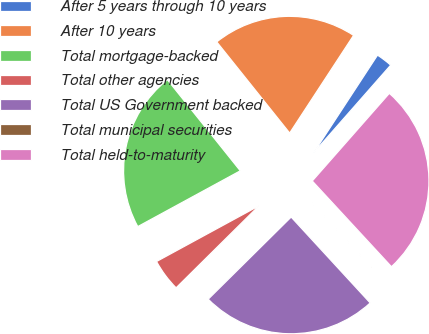Convert chart to OTSL. <chart><loc_0><loc_0><loc_500><loc_500><pie_chart><fcel>After 5 years through 10 years<fcel>After 10 years<fcel>Total mortgage-backed<fcel>Total other agencies<fcel>Total US Government backed<fcel>Total municipal securities<fcel>Total held-to-maturity<nl><fcel>2.26%<fcel>19.96%<fcel>22.19%<fcel>4.49%<fcel>24.42%<fcel>0.03%<fcel>26.65%<nl></chart> 